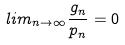Convert formula to latex. <formula><loc_0><loc_0><loc_500><loc_500>l i m _ { n \rightarrow \infty } \frac { g _ { n } } { p _ { n } } = 0</formula> 